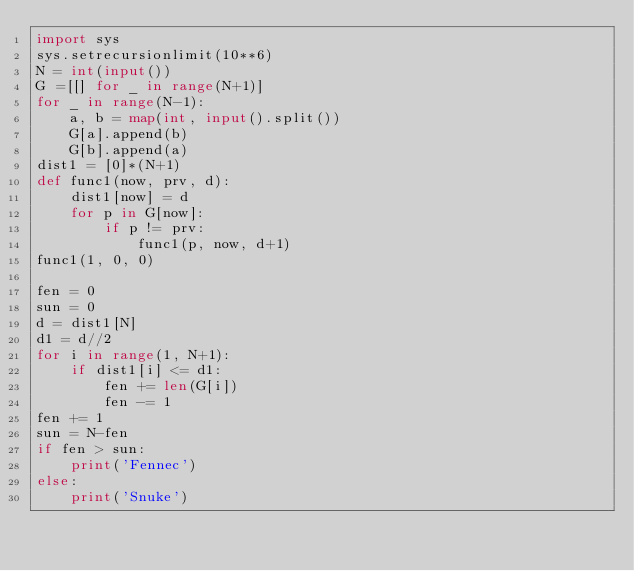Convert code to text. <code><loc_0><loc_0><loc_500><loc_500><_Python_>import sys
sys.setrecursionlimit(10**6)
N = int(input())
G =[[] for _ in range(N+1)]
for _ in range(N-1):
    a, b = map(int, input().split())
    G[a].append(b)
    G[b].append(a)
dist1 = [0]*(N+1)
def func1(now, prv, d):
    dist1[now] = d
    for p in G[now]:
        if p != prv:
            func1(p, now, d+1)
func1(1, 0, 0)

fen = 0
sun = 0
d = dist1[N]
d1 = d//2
for i in range(1, N+1):
    if dist1[i] <= d1:
        fen += len(G[i])
        fen -= 1
fen += 1
sun = N-fen
if fen > sun:
    print('Fennec')
else:
    print('Snuke')</code> 